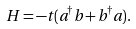<formula> <loc_0><loc_0><loc_500><loc_500>H = - t ( a ^ { \dagger } b + b ^ { \dagger } a ) .</formula> 